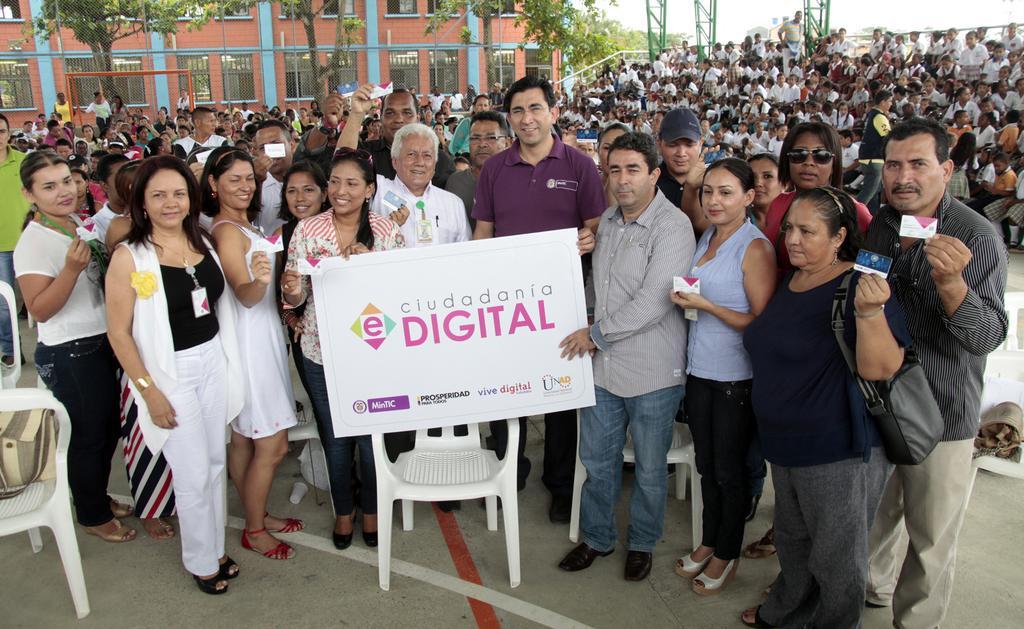Could you give a brief overview of what you see in this image? As we can see in the image there are chairs, banner, group of people here and there, current polls, trees and buildings. 